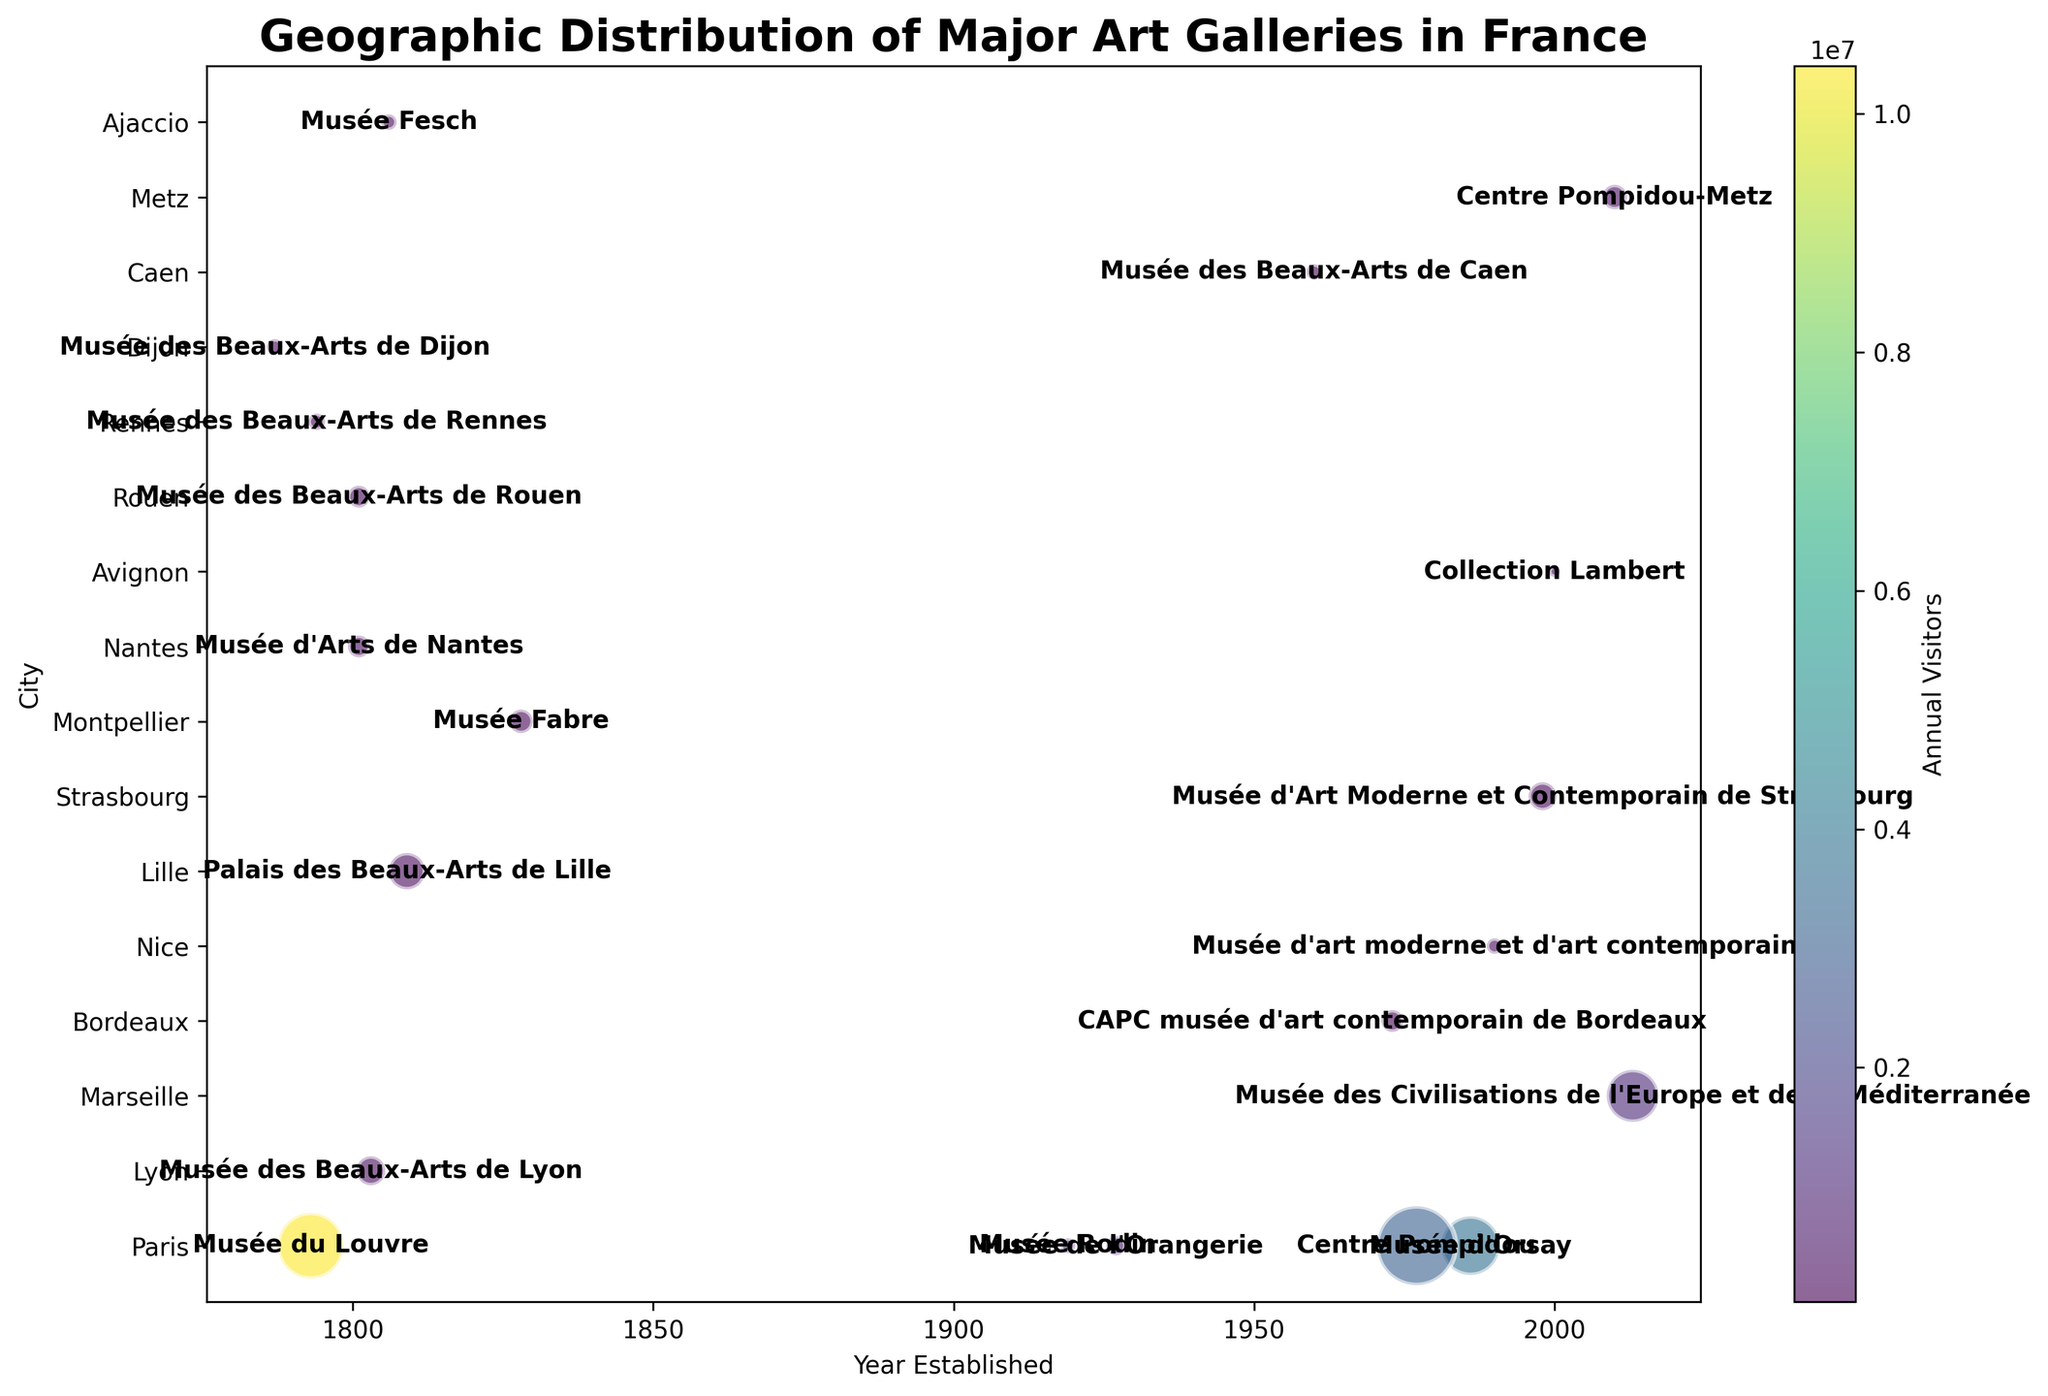Which gallery in Paris has the highest number of annual visitors? By looking at the scatter plot and focusing on Paris-based galleries, the gallery with the largest color shade (representing the highest number of annual visitors) is easily identifiable. That gallery is the Musée du Louvre.
Answer: Musée du Louvre How does the size of Centre Pompidou in Paris compare to other galleries in the same city? Visually compare the bubble sizes for galleries located in Paris. The Centre Pompidou has the largest bubble size, indicating it is the biggest gallery in terms of square meters.
Answer: Centre Pompidou is the largest Which year saw the latest established gallery among the major art galleries in France? The x-axis represents the year established. By finding the rightmost data point on the x-axis, which represents the latest year, the gallery is the Musée des Civilisations de l'Europe et de la Méditerranée established in 2013.
Answer: 2013 What is the difference in the number of annual visitors between Musée du Louvre and Musée d'Orsay? Identify the color shade of both galleries representing their annual visitors. Musée du Louvre has 10,400,000 visitors while Musée d'Orsay has 3,700,000 visitors. Calculate the difference: 10,400,000 - 3,700,000.
Answer: 6,700,000 Which gallery established in the 18th century has the smallest size in square meters? Focus on the galleries established before 1801. Compare the bubble sizes. The Musée des Beaux-Arts de Rennes, established in 1794, has the smallest bubble size among them.
Answer: Musée des Beaux-Arts de Rennes Among the galleries in cities other than Paris, which has the highest number of annual visitors? Exclude Paris galleries and look at the color shades for maximum number of visitors. The Musée des Civilisations de l'Europe et de la Méditerranée in Marseille with a visitor count of 1,100,000 has the highest number of annual visitors.
Answer: Musée des Civilisations de l'Europe et de la Méditerranée in Marseille Which two galleries have the same year of establishment and how do their annual visitors compare? Look along the x-axis for overlapping points indicating the same year of establishment. Musée des Beaux-Arts de Caen and Centre Pompidou-Metz, both established in 2010, can be compared by their color shades indicating annual visitors: Centre Pompidou-Metz has more visitors with 338,000 compared to Musée des Beaux-Arts de Caen with 50,000 visitors.
Answer: Centre Pompidou-Metz has more visitors What is the median year of establishment of the galleries in Lyon, Marseille, Bordeaux, Nice, and Lille? Identify and list the years of establishment of the galleries in Lyon (1803), Marseille (2013), Bordeaux (1973), Nice (1990), and Lille (1809). Arrange them in order (1803, 1809, 1973, 1990, 2013). The median year is the middle one: 1973.
Answer: 1973 